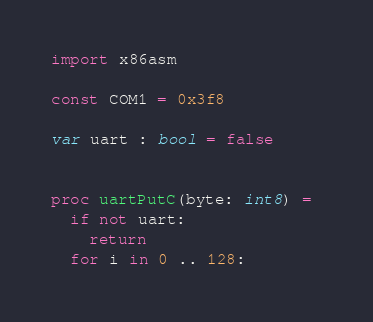Convert code to text. <code><loc_0><loc_0><loc_500><loc_500><_Nim_>import x86asm

const COM1 = 0x3f8

var uart : bool = false


proc uartPutC(byte: int8) = 
  if not uart:
    return
  for i in 0 .. 128:</code> 